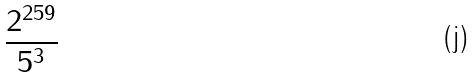<formula> <loc_0><loc_0><loc_500><loc_500>\frac { 2 ^ { 2 5 9 } } { 5 ^ { 3 } }</formula> 